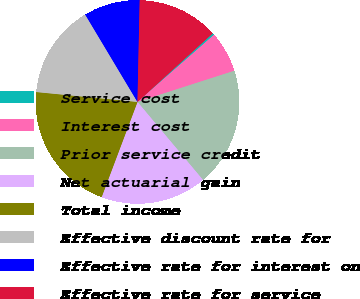<chart> <loc_0><loc_0><loc_500><loc_500><pie_chart><fcel>Service cost<fcel>Interest cost<fcel>Prior service credit<fcel>Net actuarial gain<fcel>Total income<fcel>Effective discount rate for<fcel>Effective rate for interest on<fcel>Effective rate for service<nl><fcel>0.3%<fcel>6.51%<fcel>18.84%<fcel>16.85%<fcel>20.82%<fcel>14.87%<fcel>8.93%<fcel>12.89%<nl></chart> 